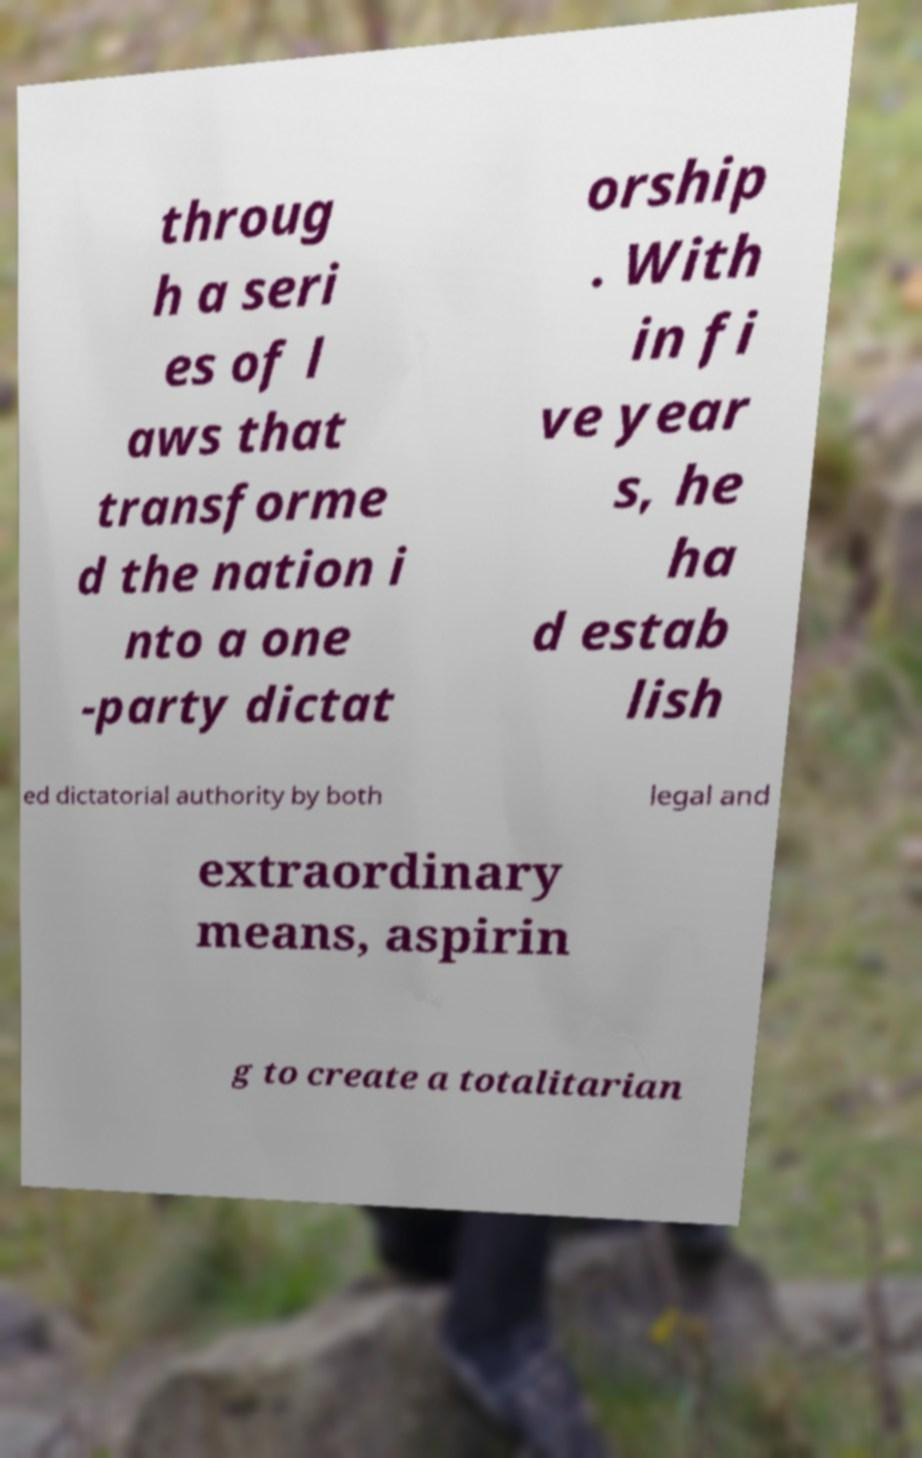Can you read and provide the text displayed in the image?This photo seems to have some interesting text. Can you extract and type it out for me? throug h a seri es of l aws that transforme d the nation i nto a one -party dictat orship . With in fi ve year s, he ha d estab lish ed dictatorial authority by both legal and extraordinary means, aspirin g to create a totalitarian 